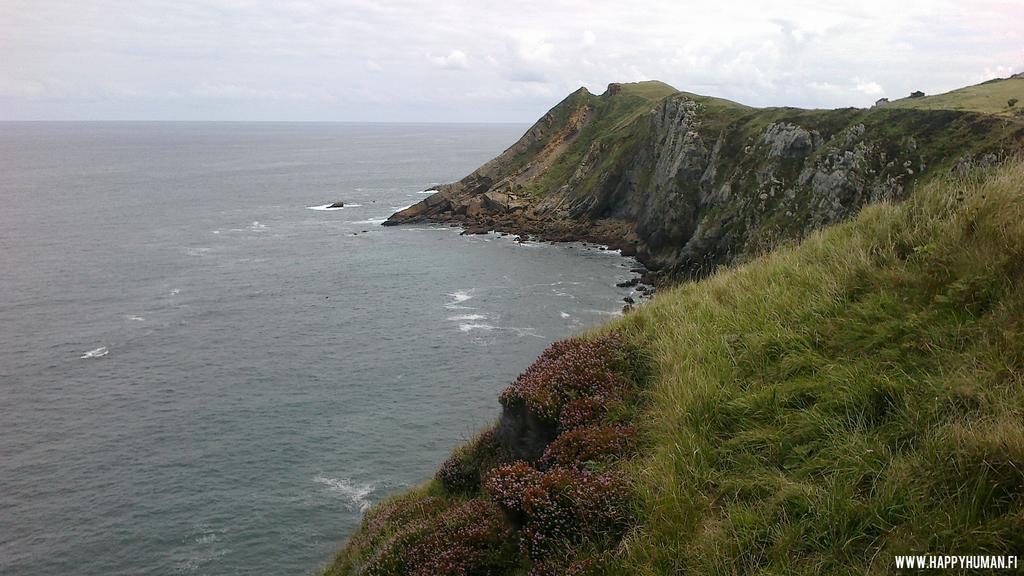In one or two sentences, can you explain what this image depicts? This is a picture taken near the shore. In the foreground of the picture there are shrubs, grass, stones and hill. On the left to the background there is water. Sky is bit cloudy. On the right to the background there are trees. 